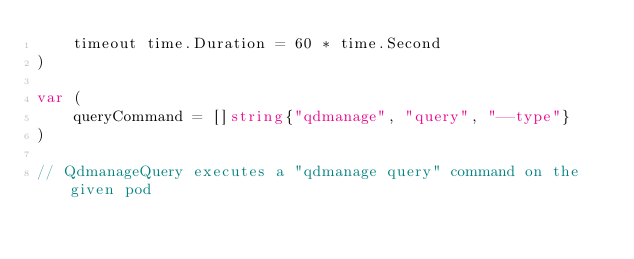Convert code to text. <code><loc_0><loc_0><loc_500><loc_500><_Go_>	timeout time.Duration = 60 * time.Second
)

var (
	queryCommand = []string{"qdmanage", "query", "--type"}
)

// QdmanageQuery executes a "qdmanage query" command on the given pod</code> 